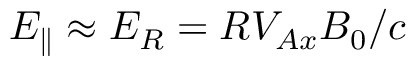Convert formula to latex. <formula><loc_0><loc_0><loc_500><loc_500>E _ { \| } \approx E _ { R } = R V _ { A x } B _ { 0 } / c</formula> 